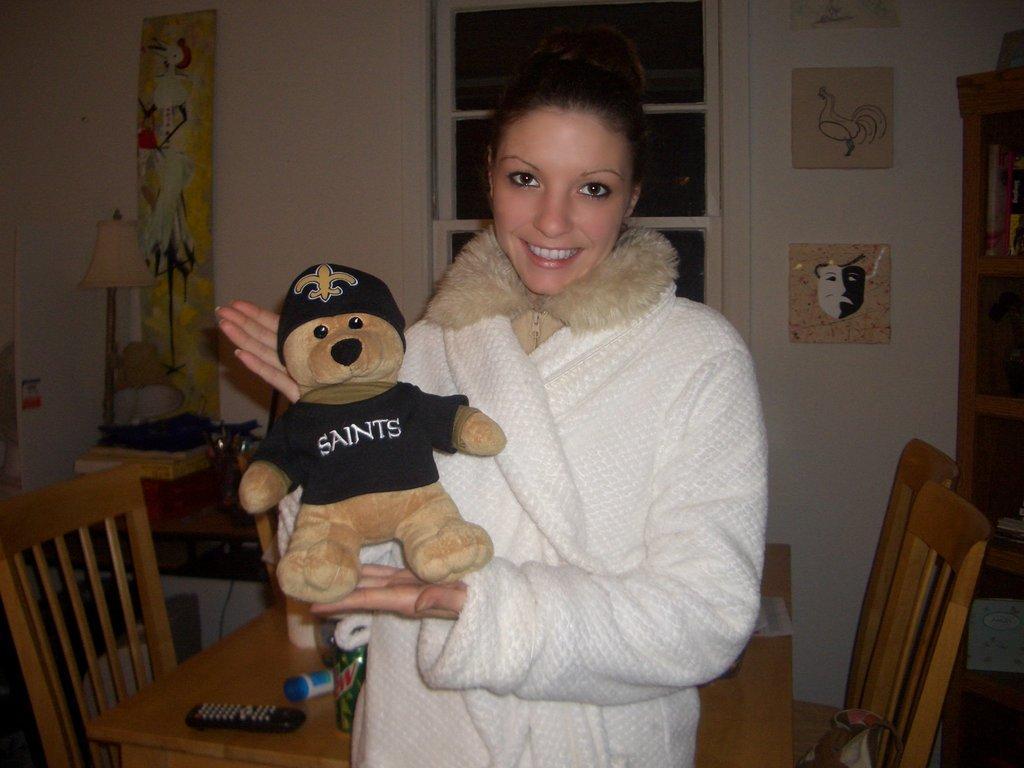In one or two sentences, can you explain what this image depicts? This image is clicked in a room. There is a table and chairs and there is a person in the middle who is wearing white sweater. She is holding a teddy bear in his hand in her hand. There is a light on the left side and there are photo frames on the right side. There is a bookshelf on the right side. On the table there is a remote, box. 